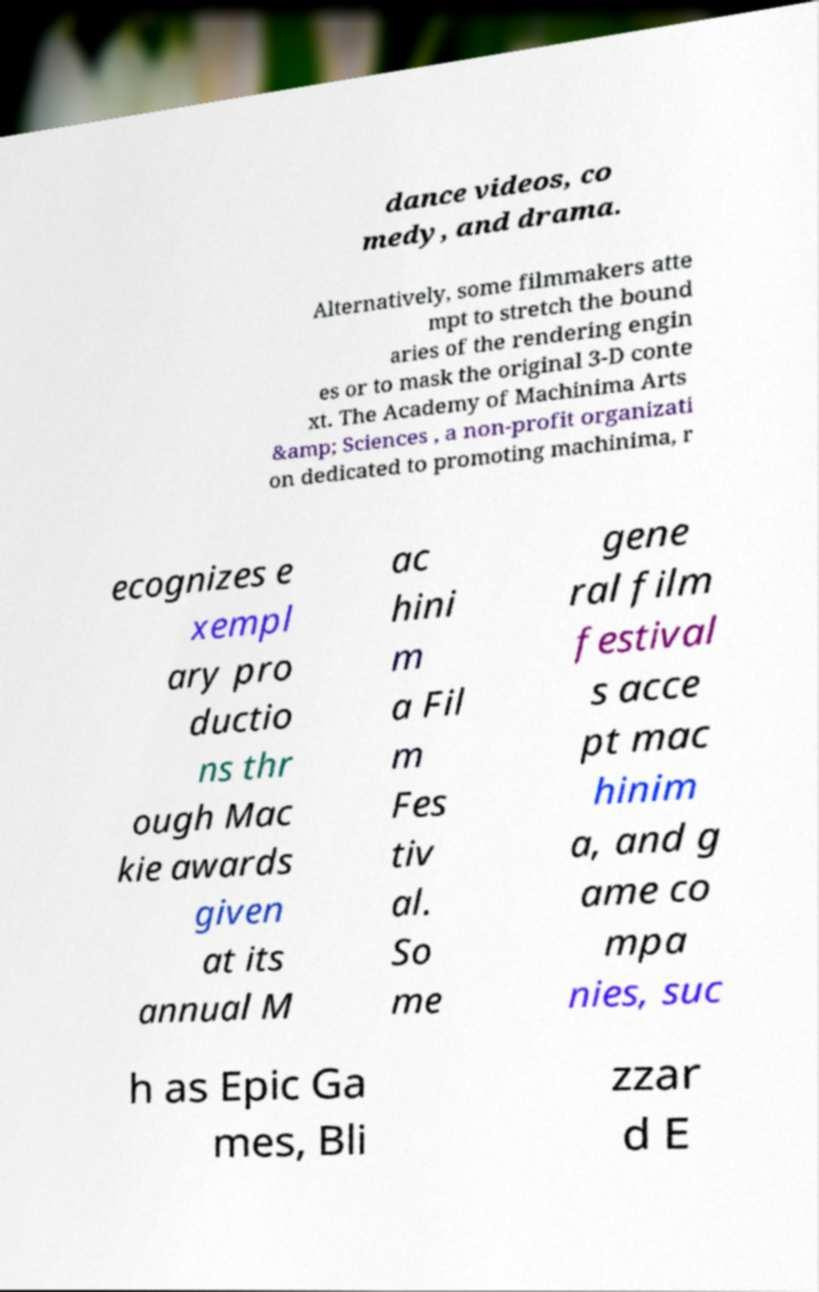Could you assist in decoding the text presented in this image and type it out clearly? dance videos, co medy, and drama. Alternatively, some filmmakers atte mpt to stretch the bound aries of the rendering engin es or to mask the original 3-D conte xt. The Academy of Machinima Arts &amp; Sciences , a non-profit organizati on dedicated to promoting machinima, r ecognizes e xempl ary pro ductio ns thr ough Mac kie awards given at its annual M ac hini m a Fil m Fes tiv al. So me gene ral film festival s acce pt mac hinim a, and g ame co mpa nies, suc h as Epic Ga mes, Bli zzar d E 